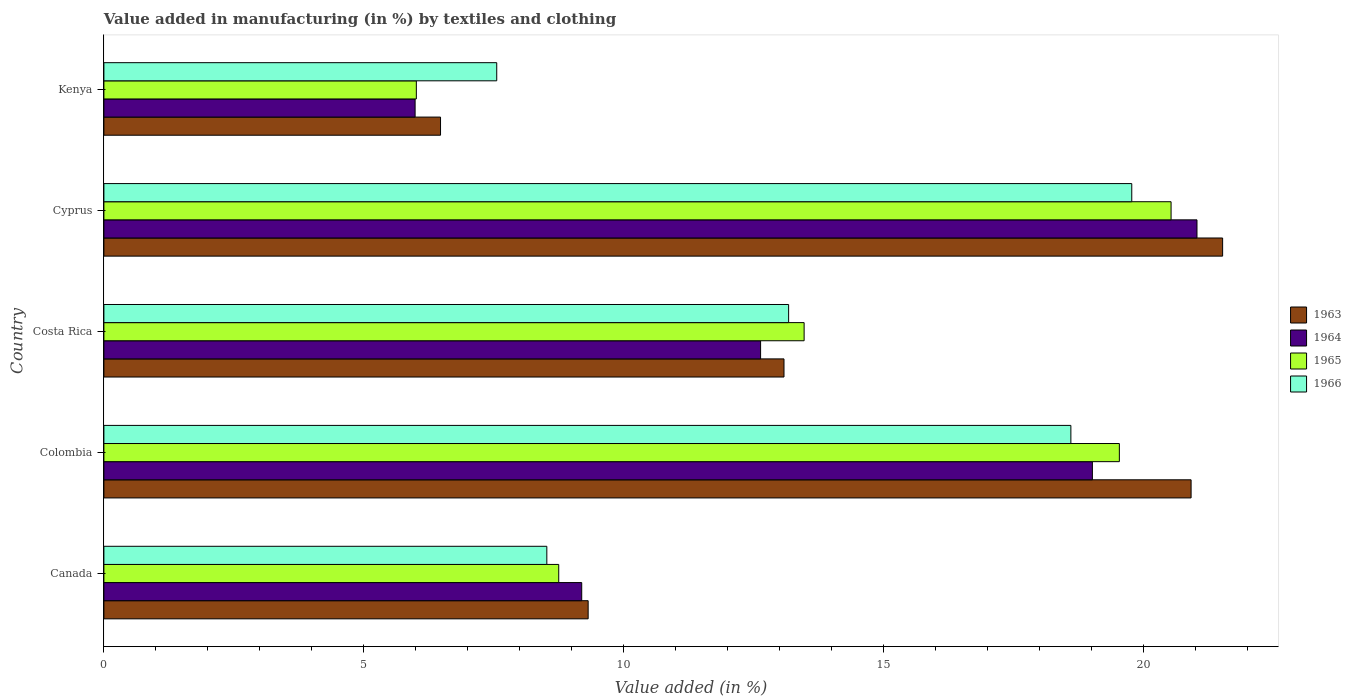Are the number of bars per tick equal to the number of legend labels?
Provide a short and direct response. Yes. Are the number of bars on each tick of the Y-axis equal?
Provide a short and direct response. Yes. How many bars are there on the 4th tick from the top?
Your response must be concise. 4. What is the percentage of value added in manufacturing by textiles and clothing in 1965 in Costa Rica?
Your answer should be compact. 13.47. Across all countries, what is the maximum percentage of value added in manufacturing by textiles and clothing in 1964?
Ensure brevity in your answer.  21.03. Across all countries, what is the minimum percentage of value added in manufacturing by textiles and clothing in 1964?
Provide a short and direct response. 5.99. In which country was the percentage of value added in manufacturing by textiles and clothing in 1964 maximum?
Provide a short and direct response. Cyprus. In which country was the percentage of value added in manufacturing by textiles and clothing in 1963 minimum?
Give a very brief answer. Kenya. What is the total percentage of value added in manufacturing by textiles and clothing in 1966 in the graph?
Keep it short and to the point. 67.63. What is the difference between the percentage of value added in manufacturing by textiles and clothing in 1963 in Costa Rica and that in Cyprus?
Your answer should be very brief. -8.44. What is the difference between the percentage of value added in manufacturing by textiles and clothing in 1964 in Colombia and the percentage of value added in manufacturing by textiles and clothing in 1963 in Kenya?
Offer a terse response. 12.54. What is the average percentage of value added in manufacturing by textiles and clothing in 1966 per country?
Your response must be concise. 13.53. What is the difference between the percentage of value added in manufacturing by textiles and clothing in 1966 and percentage of value added in manufacturing by textiles and clothing in 1963 in Canada?
Provide a succinct answer. -0.8. What is the ratio of the percentage of value added in manufacturing by textiles and clothing in 1964 in Colombia to that in Kenya?
Provide a short and direct response. 3.18. What is the difference between the highest and the second highest percentage of value added in manufacturing by textiles and clothing in 1965?
Offer a very short reply. 0.99. What is the difference between the highest and the lowest percentage of value added in manufacturing by textiles and clothing in 1965?
Provide a succinct answer. 14.52. Is it the case that in every country, the sum of the percentage of value added in manufacturing by textiles and clothing in 1963 and percentage of value added in manufacturing by textiles and clothing in 1965 is greater than the sum of percentage of value added in manufacturing by textiles and clothing in 1966 and percentage of value added in manufacturing by textiles and clothing in 1964?
Ensure brevity in your answer.  No. What does the 3rd bar from the bottom in Canada represents?
Give a very brief answer. 1965. Is it the case that in every country, the sum of the percentage of value added in manufacturing by textiles and clothing in 1965 and percentage of value added in manufacturing by textiles and clothing in 1963 is greater than the percentage of value added in manufacturing by textiles and clothing in 1964?
Give a very brief answer. Yes. How many countries are there in the graph?
Offer a terse response. 5. What is the difference between two consecutive major ticks on the X-axis?
Give a very brief answer. 5. How many legend labels are there?
Make the answer very short. 4. What is the title of the graph?
Keep it short and to the point. Value added in manufacturing (in %) by textiles and clothing. Does "1975" appear as one of the legend labels in the graph?
Offer a very short reply. No. What is the label or title of the X-axis?
Provide a short and direct response. Value added (in %). What is the label or title of the Y-axis?
Make the answer very short. Country. What is the Value added (in %) of 1963 in Canada?
Your answer should be very brief. 9.32. What is the Value added (in %) in 1964 in Canada?
Your answer should be very brief. 9.19. What is the Value added (in %) in 1965 in Canada?
Your answer should be very brief. 8.75. What is the Value added (in %) of 1966 in Canada?
Your answer should be compact. 8.52. What is the Value added (in %) in 1963 in Colombia?
Provide a short and direct response. 20.92. What is the Value added (in %) of 1964 in Colombia?
Your answer should be very brief. 19.02. What is the Value added (in %) of 1965 in Colombia?
Ensure brevity in your answer.  19.54. What is the Value added (in %) in 1966 in Colombia?
Offer a very short reply. 18.6. What is the Value added (in %) of 1963 in Costa Rica?
Provide a succinct answer. 13.08. What is the Value added (in %) in 1964 in Costa Rica?
Make the answer very short. 12.63. What is the Value added (in %) of 1965 in Costa Rica?
Provide a short and direct response. 13.47. What is the Value added (in %) of 1966 in Costa Rica?
Your answer should be compact. 13.17. What is the Value added (in %) in 1963 in Cyprus?
Make the answer very short. 21.52. What is the Value added (in %) of 1964 in Cyprus?
Your answer should be compact. 21.03. What is the Value added (in %) of 1965 in Cyprus?
Your answer should be compact. 20.53. What is the Value added (in %) of 1966 in Cyprus?
Provide a succinct answer. 19.78. What is the Value added (in %) in 1963 in Kenya?
Offer a terse response. 6.48. What is the Value added (in %) in 1964 in Kenya?
Keep it short and to the point. 5.99. What is the Value added (in %) of 1965 in Kenya?
Your answer should be very brief. 6.01. What is the Value added (in %) of 1966 in Kenya?
Your answer should be compact. 7.56. Across all countries, what is the maximum Value added (in %) in 1963?
Provide a succinct answer. 21.52. Across all countries, what is the maximum Value added (in %) of 1964?
Offer a very short reply. 21.03. Across all countries, what is the maximum Value added (in %) in 1965?
Provide a succinct answer. 20.53. Across all countries, what is the maximum Value added (in %) of 1966?
Provide a short and direct response. 19.78. Across all countries, what is the minimum Value added (in %) in 1963?
Provide a succinct answer. 6.48. Across all countries, what is the minimum Value added (in %) in 1964?
Give a very brief answer. 5.99. Across all countries, what is the minimum Value added (in %) in 1965?
Your response must be concise. 6.01. Across all countries, what is the minimum Value added (in %) in 1966?
Provide a short and direct response. 7.56. What is the total Value added (in %) of 1963 in the graph?
Your answer should be compact. 71.32. What is the total Value added (in %) of 1964 in the graph?
Your response must be concise. 67.86. What is the total Value added (in %) of 1965 in the graph?
Keep it short and to the point. 68.3. What is the total Value added (in %) of 1966 in the graph?
Provide a short and direct response. 67.63. What is the difference between the Value added (in %) of 1963 in Canada and that in Colombia?
Your answer should be very brief. -11.6. What is the difference between the Value added (in %) in 1964 in Canada and that in Colombia?
Your answer should be very brief. -9.82. What is the difference between the Value added (in %) in 1965 in Canada and that in Colombia?
Offer a terse response. -10.79. What is the difference between the Value added (in %) of 1966 in Canada and that in Colombia?
Provide a succinct answer. -10.08. What is the difference between the Value added (in %) of 1963 in Canada and that in Costa Rica?
Keep it short and to the point. -3.77. What is the difference between the Value added (in %) of 1964 in Canada and that in Costa Rica?
Give a very brief answer. -3.44. What is the difference between the Value added (in %) in 1965 in Canada and that in Costa Rica?
Your response must be concise. -4.72. What is the difference between the Value added (in %) in 1966 in Canada and that in Costa Rica?
Your answer should be very brief. -4.65. What is the difference between the Value added (in %) in 1963 in Canada and that in Cyprus?
Your answer should be very brief. -12.21. What is the difference between the Value added (in %) of 1964 in Canada and that in Cyprus?
Offer a very short reply. -11.84. What is the difference between the Value added (in %) in 1965 in Canada and that in Cyprus?
Make the answer very short. -11.78. What is the difference between the Value added (in %) in 1966 in Canada and that in Cyprus?
Your response must be concise. -11.25. What is the difference between the Value added (in %) of 1963 in Canada and that in Kenya?
Provide a succinct answer. 2.84. What is the difference between the Value added (in %) in 1964 in Canada and that in Kenya?
Your answer should be compact. 3.21. What is the difference between the Value added (in %) of 1965 in Canada and that in Kenya?
Offer a very short reply. 2.74. What is the difference between the Value added (in %) in 1966 in Canada and that in Kenya?
Make the answer very short. 0.96. What is the difference between the Value added (in %) of 1963 in Colombia and that in Costa Rica?
Ensure brevity in your answer.  7.83. What is the difference between the Value added (in %) of 1964 in Colombia and that in Costa Rica?
Your answer should be compact. 6.38. What is the difference between the Value added (in %) of 1965 in Colombia and that in Costa Rica?
Offer a terse response. 6.06. What is the difference between the Value added (in %) of 1966 in Colombia and that in Costa Rica?
Offer a very short reply. 5.43. What is the difference between the Value added (in %) of 1963 in Colombia and that in Cyprus?
Make the answer very short. -0.61. What is the difference between the Value added (in %) of 1964 in Colombia and that in Cyprus?
Keep it short and to the point. -2.01. What is the difference between the Value added (in %) in 1965 in Colombia and that in Cyprus?
Your answer should be very brief. -0.99. What is the difference between the Value added (in %) of 1966 in Colombia and that in Cyprus?
Your response must be concise. -1.17. What is the difference between the Value added (in %) of 1963 in Colombia and that in Kenya?
Provide a short and direct response. 14.44. What is the difference between the Value added (in %) in 1964 in Colombia and that in Kenya?
Your answer should be very brief. 13.03. What is the difference between the Value added (in %) in 1965 in Colombia and that in Kenya?
Provide a short and direct response. 13.53. What is the difference between the Value added (in %) in 1966 in Colombia and that in Kenya?
Provide a succinct answer. 11.05. What is the difference between the Value added (in %) of 1963 in Costa Rica and that in Cyprus?
Ensure brevity in your answer.  -8.44. What is the difference between the Value added (in %) in 1964 in Costa Rica and that in Cyprus?
Provide a succinct answer. -8.4. What is the difference between the Value added (in %) of 1965 in Costa Rica and that in Cyprus?
Make the answer very short. -7.06. What is the difference between the Value added (in %) of 1966 in Costa Rica and that in Cyprus?
Your response must be concise. -6.6. What is the difference between the Value added (in %) of 1963 in Costa Rica and that in Kenya?
Provide a succinct answer. 6.61. What is the difference between the Value added (in %) in 1964 in Costa Rica and that in Kenya?
Give a very brief answer. 6.65. What is the difference between the Value added (in %) in 1965 in Costa Rica and that in Kenya?
Your answer should be compact. 7.46. What is the difference between the Value added (in %) in 1966 in Costa Rica and that in Kenya?
Offer a terse response. 5.62. What is the difference between the Value added (in %) in 1963 in Cyprus and that in Kenya?
Keep it short and to the point. 15.05. What is the difference between the Value added (in %) of 1964 in Cyprus and that in Kenya?
Ensure brevity in your answer.  15.04. What is the difference between the Value added (in %) of 1965 in Cyprus and that in Kenya?
Offer a terse response. 14.52. What is the difference between the Value added (in %) in 1966 in Cyprus and that in Kenya?
Give a very brief answer. 12.22. What is the difference between the Value added (in %) in 1963 in Canada and the Value added (in %) in 1964 in Colombia?
Offer a very short reply. -9.7. What is the difference between the Value added (in %) in 1963 in Canada and the Value added (in %) in 1965 in Colombia?
Ensure brevity in your answer.  -10.22. What is the difference between the Value added (in %) in 1963 in Canada and the Value added (in %) in 1966 in Colombia?
Make the answer very short. -9.29. What is the difference between the Value added (in %) in 1964 in Canada and the Value added (in %) in 1965 in Colombia?
Provide a succinct answer. -10.34. What is the difference between the Value added (in %) of 1964 in Canada and the Value added (in %) of 1966 in Colombia?
Make the answer very short. -9.41. What is the difference between the Value added (in %) in 1965 in Canada and the Value added (in %) in 1966 in Colombia?
Provide a short and direct response. -9.85. What is the difference between the Value added (in %) in 1963 in Canada and the Value added (in %) in 1964 in Costa Rica?
Make the answer very short. -3.32. What is the difference between the Value added (in %) of 1963 in Canada and the Value added (in %) of 1965 in Costa Rica?
Offer a terse response. -4.16. What is the difference between the Value added (in %) in 1963 in Canada and the Value added (in %) in 1966 in Costa Rica?
Provide a succinct answer. -3.86. What is the difference between the Value added (in %) of 1964 in Canada and the Value added (in %) of 1965 in Costa Rica?
Give a very brief answer. -4.28. What is the difference between the Value added (in %) of 1964 in Canada and the Value added (in %) of 1966 in Costa Rica?
Keep it short and to the point. -3.98. What is the difference between the Value added (in %) in 1965 in Canada and the Value added (in %) in 1966 in Costa Rica?
Offer a terse response. -4.42. What is the difference between the Value added (in %) of 1963 in Canada and the Value added (in %) of 1964 in Cyprus?
Your response must be concise. -11.71. What is the difference between the Value added (in %) in 1963 in Canada and the Value added (in %) in 1965 in Cyprus?
Offer a terse response. -11.21. What is the difference between the Value added (in %) of 1963 in Canada and the Value added (in %) of 1966 in Cyprus?
Ensure brevity in your answer.  -10.46. What is the difference between the Value added (in %) in 1964 in Canada and the Value added (in %) in 1965 in Cyprus?
Ensure brevity in your answer.  -11.34. What is the difference between the Value added (in %) in 1964 in Canada and the Value added (in %) in 1966 in Cyprus?
Make the answer very short. -10.58. What is the difference between the Value added (in %) of 1965 in Canada and the Value added (in %) of 1966 in Cyprus?
Ensure brevity in your answer.  -11.02. What is the difference between the Value added (in %) in 1963 in Canada and the Value added (in %) in 1964 in Kenya?
Make the answer very short. 3.33. What is the difference between the Value added (in %) in 1963 in Canada and the Value added (in %) in 1965 in Kenya?
Your answer should be compact. 3.31. What is the difference between the Value added (in %) in 1963 in Canada and the Value added (in %) in 1966 in Kenya?
Keep it short and to the point. 1.76. What is the difference between the Value added (in %) of 1964 in Canada and the Value added (in %) of 1965 in Kenya?
Offer a terse response. 3.18. What is the difference between the Value added (in %) in 1964 in Canada and the Value added (in %) in 1966 in Kenya?
Ensure brevity in your answer.  1.64. What is the difference between the Value added (in %) in 1965 in Canada and the Value added (in %) in 1966 in Kenya?
Your answer should be very brief. 1.19. What is the difference between the Value added (in %) in 1963 in Colombia and the Value added (in %) in 1964 in Costa Rica?
Your response must be concise. 8.28. What is the difference between the Value added (in %) of 1963 in Colombia and the Value added (in %) of 1965 in Costa Rica?
Make the answer very short. 7.44. What is the difference between the Value added (in %) of 1963 in Colombia and the Value added (in %) of 1966 in Costa Rica?
Keep it short and to the point. 7.74. What is the difference between the Value added (in %) in 1964 in Colombia and the Value added (in %) in 1965 in Costa Rica?
Your answer should be very brief. 5.55. What is the difference between the Value added (in %) in 1964 in Colombia and the Value added (in %) in 1966 in Costa Rica?
Your answer should be very brief. 5.84. What is the difference between the Value added (in %) of 1965 in Colombia and the Value added (in %) of 1966 in Costa Rica?
Ensure brevity in your answer.  6.36. What is the difference between the Value added (in %) of 1963 in Colombia and the Value added (in %) of 1964 in Cyprus?
Give a very brief answer. -0.11. What is the difference between the Value added (in %) of 1963 in Colombia and the Value added (in %) of 1965 in Cyprus?
Offer a terse response. 0.39. What is the difference between the Value added (in %) of 1963 in Colombia and the Value added (in %) of 1966 in Cyprus?
Provide a succinct answer. 1.14. What is the difference between the Value added (in %) of 1964 in Colombia and the Value added (in %) of 1965 in Cyprus?
Offer a very short reply. -1.51. What is the difference between the Value added (in %) of 1964 in Colombia and the Value added (in %) of 1966 in Cyprus?
Give a very brief answer. -0.76. What is the difference between the Value added (in %) of 1965 in Colombia and the Value added (in %) of 1966 in Cyprus?
Provide a succinct answer. -0.24. What is the difference between the Value added (in %) in 1963 in Colombia and the Value added (in %) in 1964 in Kenya?
Offer a terse response. 14.93. What is the difference between the Value added (in %) of 1963 in Colombia and the Value added (in %) of 1965 in Kenya?
Offer a very short reply. 14.91. What is the difference between the Value added (in %) in 1963 in Colombia and the Value added (in %) in 1966 in Kenya?
Offer a very short reply. 13.36. What is the difference between the Value added (in %) of 1964 in Colombia and the Value added (in %) of 1965 in Kenya?
Provide a succinct answer. 13.01. What is the difference between the Value added (in %) in 1964 in Colombia and the Value added (in %) in 1966 in Kenya?
Your answer should be compact. 11.46. What is the difference between the Value added (in %) in 1965 in Colombia and the Value added (in %) in 1966 in Kenya?
Make the answer very short. 11.98. What is the difference between the Value added (in %) of 1963 in Costa Rica and the Value added (in %) of 1964 in Cyprus?
Your answer should be compact. -7.95. What is the difference between the Value added (in %) of 1963 in Costa Rica and the Value added (in %) of 1965 in Cyprus?
Offer a very short reply. -7.45. What is the difference between the Value added (in %) in 1963 in Costa Rica and the Value added (in %) in 1966 in Cyprus?
Ensure brevity in your answer.  -6.69. What is the difference between the Value added (in %) of 1964 in Costa Rica and the Value added (in %) of 1965 in Cyprus?
Provide a succinct answer. -7.9. What is the difference between the Value added (in %) in 1964 in Costa Rica and the Value added (in %) in 1966 in Cyprus?
Your answer should be compact. -7.14. What is the difference between the Value added (in %) in 1965 in Costa Rica and the Value added (in %) in 1966 in Cyprus?
Ensure brevity in your answer.  -6.3. What is the difference between the Value added (in %) in 1963 in Costa Rica and the Value added (in %) in 1964 in Kenya?
Your response must be concise. 7.1. What is the difference between the Value added (in %) in 1963 in Costa Rica and the Value added (in %) in 1965 in Kenya?
Your response must be concise. 7.07. What is the difference between the Value added (in %) of 1963 in Costa Rica and the Value added (in %) of 1966 in Kenya?
Provide a succinct answer. 5.53. What is the difference between the Value added (in %) of 1964 in Costa Rica and the Value added (in %) of 1965 in Kenya?
Give a very brief answer. 6.62. What is the difference between the Value added (in %) in 1964 in Costa Rica and the Value added (in %) in 1966 in Kenya?
Give a very brief answer. 5.08. What is the difference between the Value added (in %) of 1965 in Costa Rica and the Value added (in %) of 1966 in Kenya?
Ensure brevity in your answer.  5.91. What is the difference between the Value added (in %) of 1963 in Cyprus and the Value added (in %) of 1964 in Kenya?
Give a very brief answer. 15.54. What is the difference between the Value added (in %) of 1963 in Cyprus and the Value added (in %) of 1965 in Kenya?
Offer a very short reply. 15.51. What is the difference between the Value added (in %) in 1963 in Cyprus and the Value added (in %) in 1966 in Kenya?
Your response must be concise. 13.97. What is the difference between the Value added (in %) in 1964 in Cyprus and the Value added (in %) in 1965 in Kenya?
Provide a succinct answer. 15.02. What is the difference between the Value added (in %) in 1964 in Cyprus and the Value added (in %) in 1966 in Kenya?
Keep it short and to the point. 13.47. What is the difference between the Value added (in %) of 1965 in Cyprus and the Value added (in %) of 1966 in Kenya?
Offer a very short reply. 12.97. What is the average Value added (in %) in 1963 per country?
Provide a short and direct response. 14.26. What is the average Value added (in %) of 1964 per country?
Your answer should be compact. 13.57. What is the average Value added (in %) of 1965 per country?
Offer a very short reply. 13.66. What is the average Value added (in %) in 1966 per country?
Your answer should be compact. 13.53. What is the difference between the Value added (in %) of 1963 and Value added (in %) of 1964 in Canada?
Keep it short and to the point. 0.12. What is the difference between the Value added (in %) of 1963 and Value added (in %) of 1965 in Canada?
Give a very brief answer. 0.57. What is the difference between the Value added (in %) in 1963 and Value added (in %) in 1966 in Canada?
Your answer should be very brief. 0.8. What is the difference between the Value added (in %) of 1964 and Value added (in %) of 1965 in Canada?
Provide a succinct answer. 0.44. What is the difference between the Value added (in %) of 1964 and Value added (in %) of 1966 in Canada?
Your response must be concise. 0.67. What is the difference between the Value added (in %) of 1965 and Value added (in %) of 1966 in Canada?
Give a very brief answer. 0.23. What is the difference between the Value added (in %) in 1963 and Value added (in %) in 1964 in Colombia?
Keep it short and to the point. 1.9. What is the difference between the Value added (in %) of 1963 and Value added (in %) of 1965 in Colombia?
Provide a succinct answer. 1.38. What is the difference between the Value added (in %) in 1963 and Value added (in %) in 1966 in Colombia?
Provide a short and direct response. 2.31. What is the difference between the Value added (in %) in 1964 and Value added (in %) in 1965 in Colombia?
Give a very brief answer. -0.52. What is the difference between the Value added (in %) in 1964 and Value added (in %) in 1966 in Colombia?
Ensure brevity in your answer.  0.41. What is the difference between the Value added (in %) in 1965 and Value added (in %) in 1966 in Colombia?
Offer a terse response. 0.93. What is the difference between the Value added (in %) of 1963 and Value added (in %) of 1964 in Costa Rica?
Your response must be concise. 0.45. What is the difference between the Value added (in %) in 1963 and Value added (in %) in 1965 in Costa Rica?
Provide a short and direct response. -0.39. What is the difference between the Value added (in %) in 1963 and Value added (in %) in 1966 in Costa Rica?
Provide a short and direct response. -0.09. What is the difference between the Value added (in %) in 1964 and Value added (in %) in 1965 in Costa Rica?
Your answer should be very brief. -0.84. What is the difference between the Value added (in %) of 1964 and Value added (in %) of 1966 in Costa Rica?
Provide a succinct answer. -0.54. What is the difference between the Value added (in %) in 1965 and Value added (in %) in 1966 in Costa Rica?
Provide a short and direct response. 0.3. What is the difference between the Value added (in %) of 1963 and Value added (in %) of 1964 in Cyprus?
Make the answer very short. 0.49. What is the difference between the Value added (in %) in 1963 and Value added (in %) in 1965 in Cyprus?
Offer a very short reply. 0.99. What is the difference between the Value added (in %) of 1963 and Value added (in %) of 1966 in Cyprus?
Offer a very short reply. 1.75. What is the difference between the Value added (in %) of 1964 and Value added (in %) of 1965 in Cyprus?
Make the answer very short. 0.5. What is the difference between the Value added (in %) in 1964 and Value added (in %) in 1966 in Cyprus?
Keep it short and to the point. 1.25. What is the difference between the Value added (in %) of 1965 and Value added (in %) of 1966 in Cyprus?
Keep it short and to the point. 0.76. What is the difference between the Value added (in %) in 1963 and Value added (in %) in 1964 in Kenya?
Your answer should be compact. 0.49. What is the difference between the Value added (in %) in 1963 and Value added (in %) in 1965 in Kenya?
Your response must be concise. 0.47. What is the difference between the Value added (in %) in 1963 and Value added (in %) in 1966 in Kenya?
Give a very brief answer. -1.08. What is the difference between the Value added (in %) of 1964 and Value added (in %) of 1965 in Kenya?
Ensure brevity in your answer.  -0.02. What is the difference between the Value added (in %) of 1964 and Value added (in %) of 1966 in Kenya?
Your answer should be very brief. -1.57. What is the difference between the Value added (in %) in 1965 and Value added (in %) in 1966 in Kenya?
Offer a very short reply. -1.55. What is the ratio of the Value added (in %) of 1963 in Canada to that in Colombia?
Ensure brevity in your answer.  0.45. What is the ratio of the Value added (in %) in 1964 in Canada to that in Colombia?
Give a very brief answer. 0.48. What is the ratio of the Value added (in %) of 1965 in Canada to that in Colombia?
Ensure brevity in your answer.  0.45. What is the ratio of the Value added (in %) in 1966 in Canada to that in Colombia?
Your response must be concise. 0.46. What is the ratio of the Value added (in %) in 1963 in Canada to that in Costa Rica?
Your answer should be compact. 0.71. What is the ratio of the Value added (in %) in 1964 in Canada to that in Costa Rica?
Ensure brevity in your answer.  0.73. What is the ratio of the Value added (in %) in 1965 in Canada to that in Costa Rica?
Your answer should be very brief. 0.65. What is the ratio of the Value added (in %) in 1966 in Canada to that in Costa Rica?
Your answer should be very brief. 0.65. What is the ratio of the Value added (in %) in 1963 in Canada to that in Cyprus?
Your answer should be compact. 0.43. What is the ratio of the Value added (in %) in 1964 in Canada to that in Cyprus?
Offer a terse response. 0.44. What is the ratio of the Value added (in %) of 1965 in Canada to that in Cyprus?
Your answer should be compact. 0.43. What is the ratio of the Value added (in %) of 1966 in Canada to that in Cyprus?
Your answer should be very brief. 0.43. What is the ratio of the Value added (in %) in 1963 in Canada to that in Kenya?
Give a very brief answer. 1.44. What is the ratio of the Value added (in %) of 1964 in Canada to that in Kenya?
Your answer should be compact. 1.54. What is the ratio of the Value added (in %) in 1965 in Canada to that in Kenya?
Offer a terse response. 1.46. What is the ratio of the Value added (in %) in 1966 in Canada to that in Kenya?
Your answer should be compact. 1.13. What is the ratio of the Value added (in %) in 1963 in Colombia to that in Costa Rica?
Give a very brief answer. 1.6. What is the ratio of the Value added (in %) in 1964 in Colombia to that in Costa Rica?
Provide a short and direct response. 1.51. What is the ratio of the Value added (in %) of 1965 in Colombia to that in Costa Rica?
Make the answer very short. 1.45. What is the ratio of the Value added (in %) of 1966 in Colombia to that in Costa Rica?
Offer a very short reply. 1.41. What is the ratio of the Value added (in %) of 1963 in Colombia to that in Cyprus?
Your answer should be very brief. 0.97. What is the ratio of the Value added (in %) in 1964 in Colombia to that in Cyprus?
Offer a very short reply. 0.9. What is the ratio of the Value added (in %) in 1965 in Colombia to that in Cyprus?
Your answer should be compact. 0.95. What is the ratio of the Value added (in %) in 1966 in Colombia to that in Cyprus?
Your response must be concise. 0.94. What is the ratio of the Value added (in %) of 1963 in Colombia to that in Kenya?
Your answer should be compact. 3.23. What is the ratio of the Value added (in %) of 1964 in Colombia to that in Kenya?
Provide a short and direct response. 3.18. What is the ratio of the Value added (in %) in 1966 in Colombia to that in Kenya?
Offer a terse response. 2.46. What is the ratio of the Value added (in %) in 1963 in Costa Rica to that in Cyprus?
Your answer should be very brief. 0.61. What is the ratio of the Value added (in %) of 1964 in Costa Rica to that in Cyprus?
Keep it short and to the point. 0.6. What is the ratio of the Value added (in %) of 1965 in Costa Rica to that in Cyprus?
Your answer should be very brief. 0.66. What is the ratio of the Value added (in %) of 1966 in Costa Rica to that in Cyprus?
Your response must be concise. 0.67. What is the ratio of the Value added (in %) of 1963 in Costa Rica to that in Kenya?
Provide a short and direct response. 2.02. What is the ratio of the Value added (in %) of 1964 in Costa Rica to that in Kenya?
Provide a succinct answer. 2.11. What is the ratio of the Value added (in %) in 1965 in Costa Rica to that in Kenya?
Your answer should be very brief. 2.24. What is the ratio of the Value added (in %) in 1966 in Costa Rica to that in Kenya?
Your answer should be compact. 1.74. What is the ratio of the Value added (in %) of 1963 in Cyprus to that in Kenya?
Your response must be concise. 3.32. What is the ratio of the Value added (in %) in 1964 in Cyprus to that in Kenya?
Provide a succinct answer. 3.51. What is the ratio of the Value added (in %) in 1965 in Cyprus to that in Kenya?
Provide a short and direct response. 3.42. What is the ratio of the Value added (in %) of 1966 in Cyprus to that in Kenya?
Your answer should be very brief. 2.62. What is the difference between the highest and the second highest Value added (in %) in 1963?
Keep it short and to the point. 0.61. What is the difference between the highest and the second highest Value added (in %) in 1964?
Offer a terse response. 2.01. What is the difference between the highest and the second highest Value added (in %) of 1965?
Your response must be concise. 0.99. What is the difference between the highest and the second highest Value added (in %) in 1966?
Offer a terse response. 1.17. What is the difference between the highest and the lowest Value added (in %) in 1963?
Give a very brief answer. 15.05. What is the difference between the highest and the lowest Value added (in %) in 1964?
Ensure brevity in your answer.  15.04. What is the difference between the highest and the lowest Value added (in %) of 1965?
Offer a very short reply. 14.52. What is the difference between the highest and the lowest Value added (in %) in 1966?
Your answer should be compact. 12.22. 